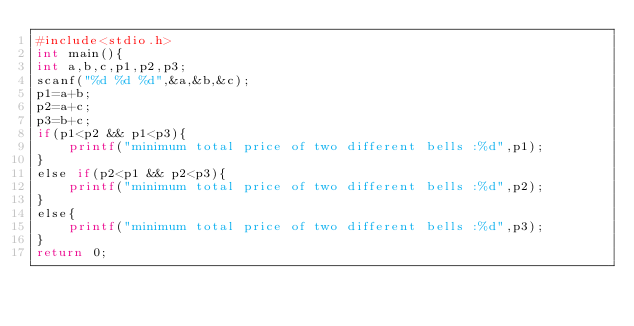Convert code to text. <code><loc_0><loc_0><loc_500><loc_500><_Awk_>#include<stdio.h>
int main(){
int a,b,c,p1,p2,p3;
scanf("%d %d %d",&a,&b,&c);
p1=a+b;
p2=a+c;
p3=b+c;
if(p1<p2 && p1<p3){
    printf("minimum total price of two different bells :%d",p1);
}
else if(p2<p1 && p2<p3){
    printf("minimum total price of two different bells :%d",p2);
}
else{
    printf("minimum total price of two different bells :%d",p3);
}
return 0;</code> 